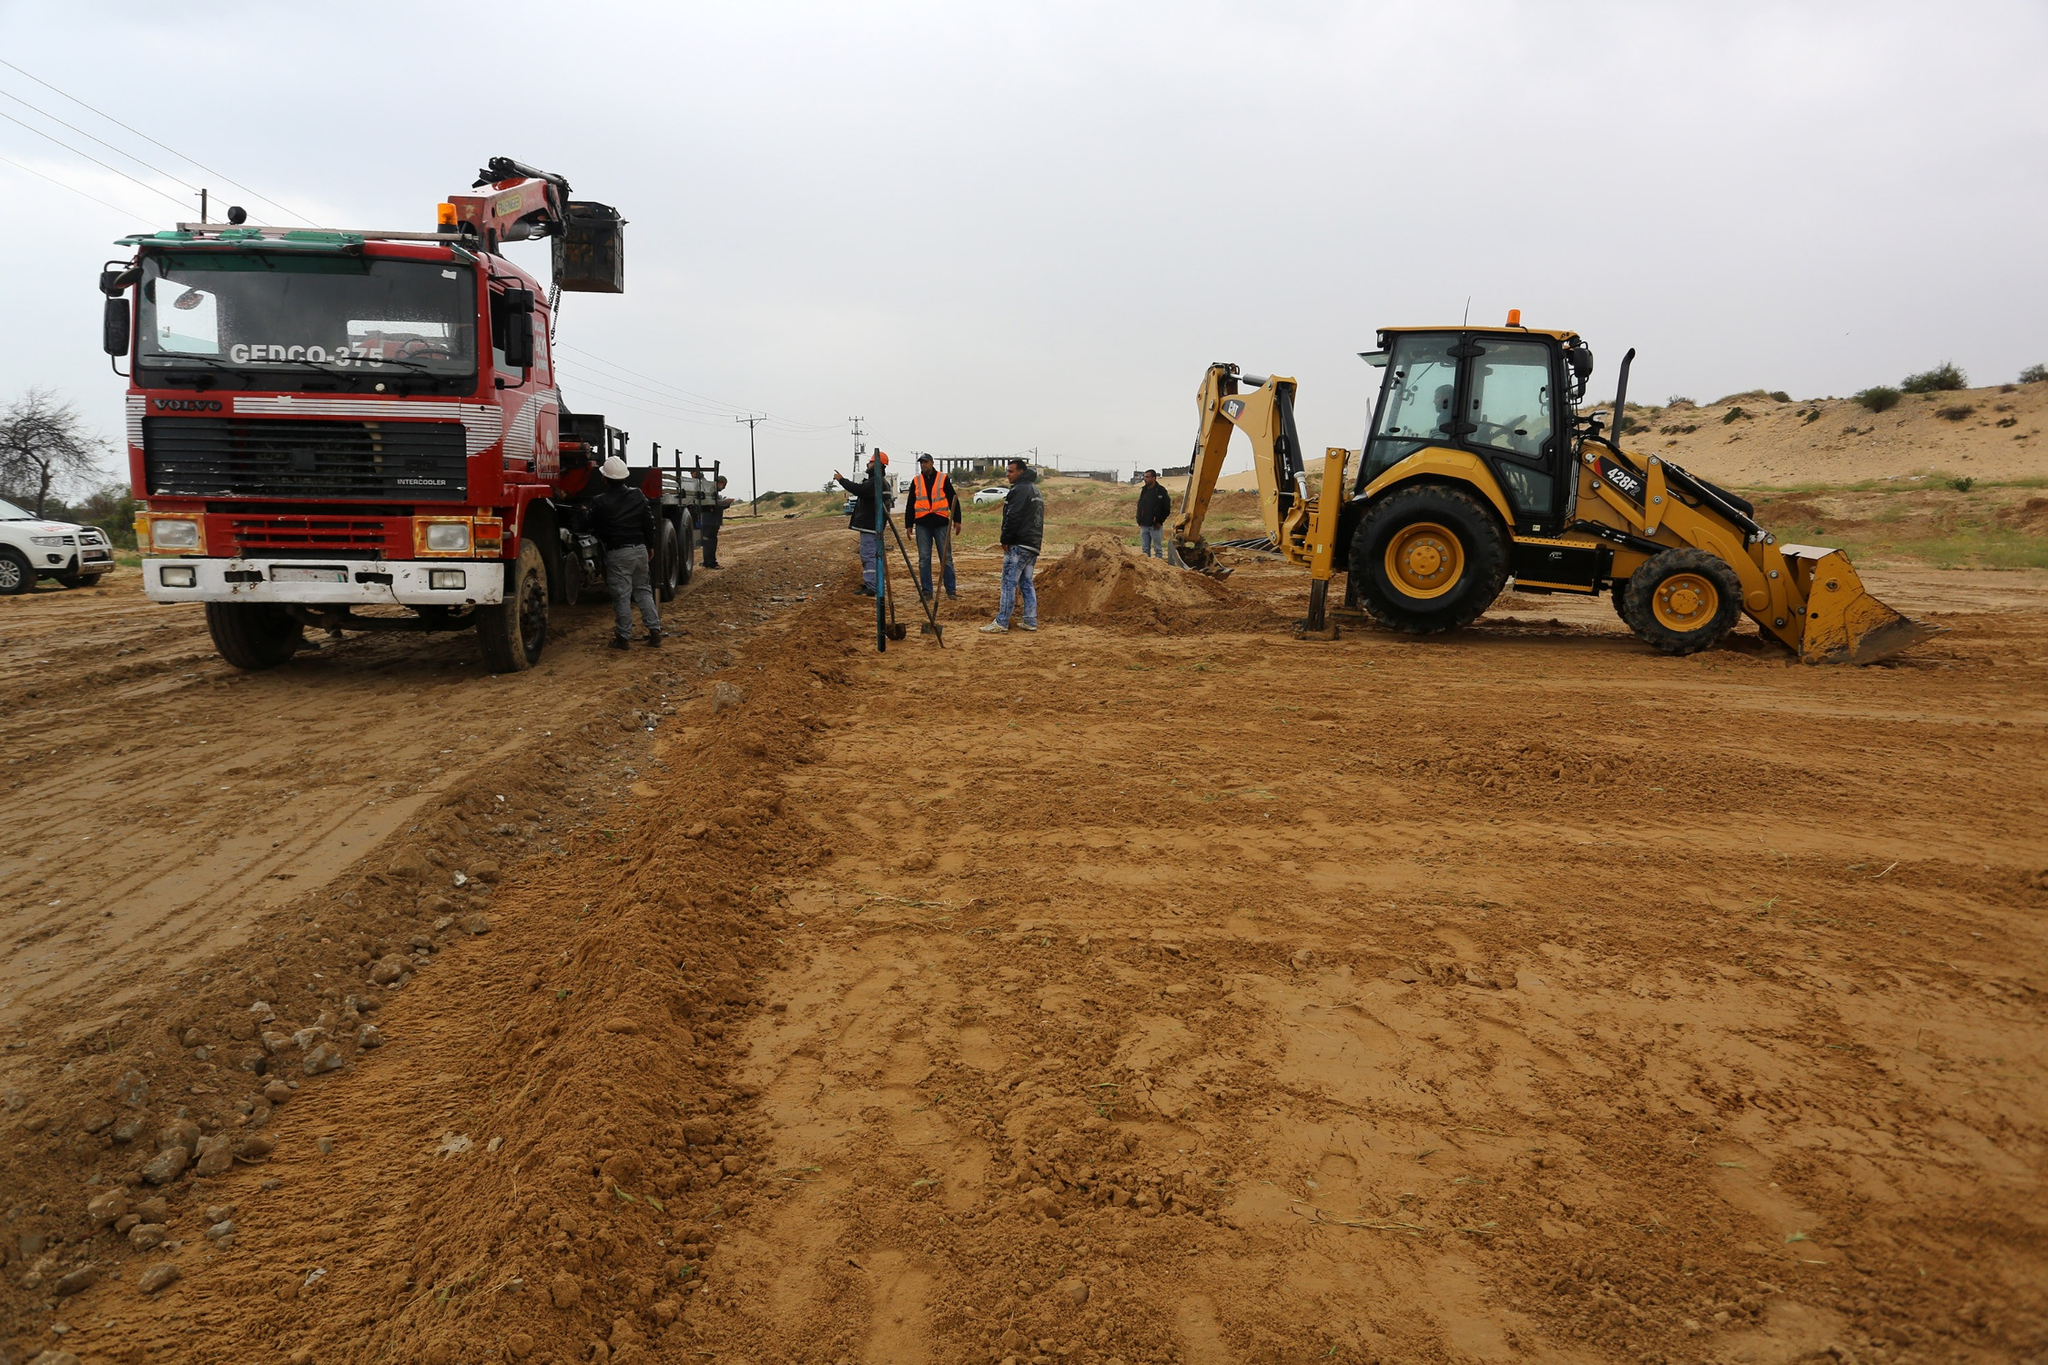If a time traveler from the past witnessed this scene, what do you think they would be most astonished by? A time traveler from the past would likely be most astonished by the sheer scale and capability of the construction machinery. The size and power of the crane-equipped truck and bulldozer, capable of moving immense amounts of earth with ease, would be a stark contrast to the labor-intensive methods they are familiar with. The efficiency and coordination between human workers and machines would also be remarkable. Additionally, they might be impressed by the safety gear and measures in place, highlighting advancements in worker protection and productivity. 